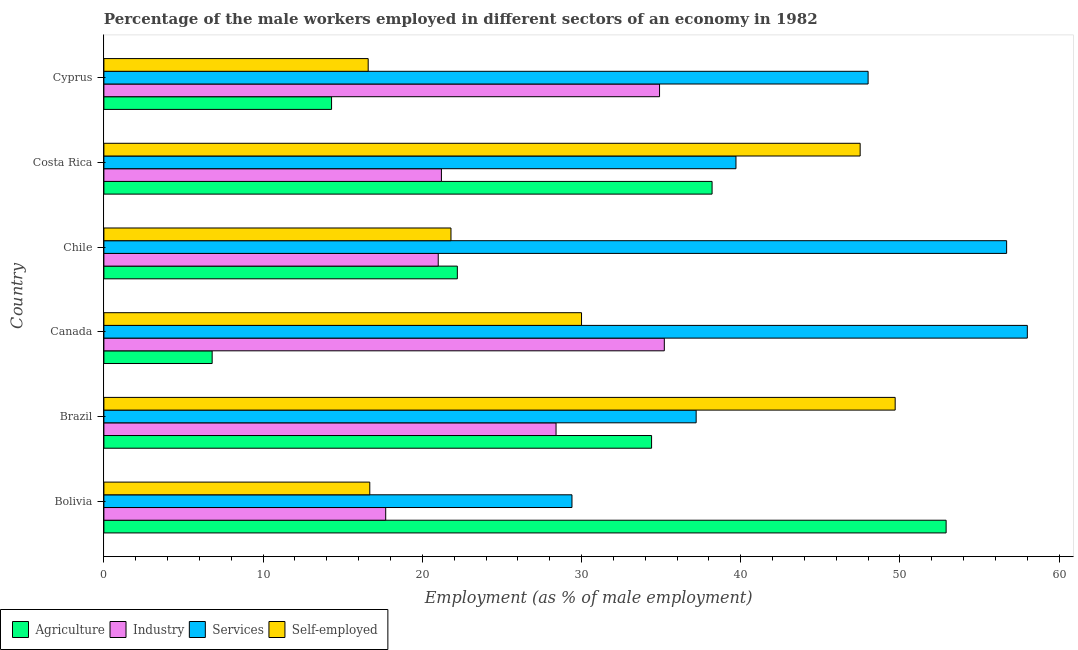How many different coloured bars are there?
Provide a short and direct response. 4. Are the number of bars per tick equal to the number of legend labels?
Ensure brevity in your answer.  Yes. Are the number of bars on each tick of the Y-axis equal?
Your answer should be compact. Yes. How many bars are there on the 1st tick from the top?
Offer a very short reply. 4. How many bars are there on the 5th tick from the bottom?
Offer a terse response. 4. In how many cases, is the number of bars for a given country not equal to the number of legend labels?
Provide a short and direct response. 0. What is the percentage of self employed male workers in Bolivia?
Your response must be concise. 16.7. Across all countries, what is the maximum percentage of self employed male workers?
Provide a succinct answer. 49.7. Across all countries, what is the minimum percentage of male workers in industry?
Make the answer very short. 17.7. What is the total percentage of male workers in services in the graph?
Give a very brief answer. 269. What is the difference between the percentage of male workers in agriculture in Brazil and that in Canada?
Give a very brief answer. 27.6. What is the difference between the percentage of male workers in services in Canada and the percentage of male workers in industry in Bolivia?
Offer a terse response. 40.3. What is the average percentage of male workers in agriculture per country?
Your answer should be very brief. 28.13. What is the difference between the percentage of male workers in industry and percentage of self employed male workers in Brazil?
Your answer should be very brief. -21.3. What is the ratio of the percentage of male workers in services in Bolivia to that in Cyprus?
Provide a short and direct response. 0.61. Is the percentage of male workers in industry in Brazil less than that in Chile?
Provide a succinct answer. No. Is the difference between the percentage of self employed male workers in Canada and Cyprus greater than the difference between the percentage of male workers in agriculture in Canada and Cyprus?
Keep it short and to the point. Yes. What is the difference between the highest and the lowest percentage of male workers in agriculture?
Keep it short and to the point. 46.1. In how many countries, is the percentage of male workers in services greater than the average percentage of male workers in services taken over all countries?
Provide a succinct answer. 3. Is the sum of the percentage of male workers in services in Bolivia and Brazil greater than the maximum percentage of male workers in agriculture across all countries?
Keep it short and to the point. Yes. Is it the case that in every country, the sum of the percentage of male workers in industry and percentage of male workers in services is greater than the sum of percentage of male workers in agriculture and percentage of self employed male workers?
Your answer should be very brief. Yes. What does the 4th bar from the top in Costa Rica represents?
Offer a very short reply. Agriculture. What does the 2nd bar from the bottom in Chile represents?
Your answer should be very brief. Industry. Are all the bars in the graph horizontal?
Make the answer very short. Yes. How many countries are there in the graph?
Offer a very short reply. 6. Does the graph contain any zero values?
Ensure brevity in your answer.  No. What is the title of the graph?
Provide a short and direct response. Percentage of the male workers employed in different sectors of an economy in 1982. Does "Mammal species" appear as one of the legend labels in the graph?
Offer a terse response. No. What is the label or title of the X-axis?
Make the answer very short. Employment (as % of male employment). What is the label or title of the Y-axis?
Give a very brief answer. Country. What is the Employment (as % of male employment) of Agriculture in Bolivia?
Your answer should be very brief. 52.9. What is the Employment (as % of male employment) in Industry in Bolivia?
Keep it short and to the point. 17.7. What is the Employment (as % of male employment) of Services in Bolivia?
Offer a terse response. 29.4. What is the Employment (as % of male employment) in Self-employed in Bolivia?
Provide a short and direct response. 16.7. What is the Employment (as % of male employment) in Agriculture in Brazil?
Keep it short and to the point. 34.4. What is the Employment (as % of male employment) in Industry in Brazil?
Your response must be concise. 28.4. What is the Employment (as % of male employment) of Services in Brazil?
Provide a succinct answer. 37.2. What is the Employment (as % of male employment) in Self-employed in Brazil?
Give a very brief answer. 49.7. What is the Employment (as % of male employment) of Agriculture in Canada?
Keep it short and to the point. 6.8. What is the Employment (as % of male employment) of Industry in Canada?
Offer a terse response. 35.2. What is the Employment (as % of male employment) in Agriculture in Chile?
Ensure brevity in your answer.  22.2. What is the Employment (as % of male employment) of Industry in Chile?
Your answer should be compact. 21. What is the Employment (as % of male employment) in Services in Chile?
Provide a short and direct response. 56.7. What is the Employment (as % of male employment) in Self-employed in Chile?
Ensure brevity in your answer.  21.8. What is the Employment (as % of male employment) of Agriculture in Costa Rica?
Keep it short and to the point. 38.2. What is the Employment (as % of male employment) of Industry in Costa Rica?
Your answer should be compact. 21.2. What is the Employment (as % of male employment) of Services in Costa Rica?
Your answer should be very brief. 39.7. What is the Employment (as % of male employment) of Self-employed in Costa Rica?
Keep it short and to the point. 47.5. What is the Employment (as % of male employment) in Agriculture in Cyprus?
Provide a succinct answer. 14.3. What is the Employment (as % of male employment) of Industry in Cyprus?
Your response must be concise. 34.9. What is the Employment (as % of male employment) of Self-employed in Cyprus?
Provide a short and direct response. 16.6. Across all countries, what is the maximum Employment (as % of male employment) in Agriculture?
Offer a terse response. 52.9. Across all countries, what is the maximum Employment (as % of male employment) of Industry?
Your answer should be very brief. 35.2. Across all countries, what is the maximum Employment (as % of male employment) of Services?
Make the answer very short. 58. Across all countries, what is the maximum Employment (as % of male employment) in Self-employed?
Your answer should be compact. 49.7. Across all countries, what is the minimum Employment (as % of male employment) in Agriculture?
Give a very brief answer. 6.8. Across all countries, what is the minimum Employment (as % of male employment) in Industry?
Your answer should be very brief. 17.7. Across all countries, what is the minimum Employment (as % of male employment) in Services?
Make the answer very short. 29.4. Across all countries, what is the minimum Employment (as % of male employment) in Self-employed?
Keep it short and to the point. 16.6. What is the total Employment (as % of male employment) of Agriculture in the graph?
Keep it short and to the point. 168.8. What is the total Employment (as % of male employment) of Industry in the graph?
Your answer should be very brief. 158.4. What is the total Employment (as % of male employment) of Services in the graph?
Provide a succinct answer. 269. What is the total Employment (as % of male employment) of Self-employed in the graph?
Your response must be concise. 182.3. What is the difference between the Employment (as % of male employment) of Industry in Bolivia and that in Brazil?
Offer a very short reply. -10.7. What is the difference between the Employment (as % of male employment) in Self-employed in Bolivia and that in Brazil?
Provide a succinct answer. -33. What is the difference between the Employment (as % of male employment) of Agriculture in Bolivia and that in Canada?
Give a very brief answer. 46.1. What is the difference between the Employment (as % of male employment) in Industry in Bolivia and that in Canada?
Your response must be concise. -17.5. What is the difference between the Employment (as % of male employment) of Services in Bolivia and that in Canada?
Offer a very short reply. -28.6. What is the difference between the Employment (as % of male employment) in Agriculture in Bolivia and that in Chile?
Provide a succinct answer. 30.7. What is the difference between the Employment (as % of male employment) in Industry in Bolivia and that in Chile?
Give a very brief answer. -3.3. What is the difference between the Employment (as % of male employment) of Services in Bolivia and that in Chile?
Your response must be concise. -27.3. What is the difference between the Employment (as % of male employment) in Self-employed in Bolivia and that in Chile?
Your response must be concise. -5.1. What is the difference between the Employment (as % of male employment) of Agriculture in Bolivia and that in Costa Rica?
Offer a terse response. 14.7. What is the difference between the Employment (as % of male employment) in Services in Bolivia and that in Costa Rica?
Keep it short and to the point. -10.3. What is the difference between the Employment (as % of male employment) of Self-employed in Bolivia and that in Costa Rica?
Your answer should be very brief. -30.8. What is the difference between the Employment (as % of male employment) in Agriculture in Bolivia and that in Cyprus?
Provide a succinct answer. 38.6. What is the difference between the Employment (as % of male employment) of Industry in Bolivia and that in Cyprus?
Make the answer very short. -17.2. What is the difference between the Employment (as % of male employment) in Services in Bolivia and that in Cyprus?
Offer a terse response. -18.6. What is the difference between the Employment (as % of male employment) of Self-employed in Bolivia and that in Cyprus?
Provide a succinct answer. 0.1. What is the difference between the Employment (as % of male employment) in Agriculture in Brazil and that in Canada?
Keep it short and to the point. 27.6. What is the difference between the Employment (as % of male employment) in Industry in Brazil and that in Canada?
Your answer should be compact. -6.8. What is the difference between the Employment (as % of male employment) in Services in Brazil and that in Canada?
Keep it short and to the point. -20.8. What is the difference between the Employment (as % of male employment) of Agriculture in Brazil and that in Chile?
Provide a short and direct response. 12.2. What is the difference between the Employment (as % of male employment) of Industry in Brazil and that in Chile?
Ensure brevity in your answer.  7.4. What is the difference between the Employment (as % of male employment) in Services in Brazil and that in Chile?
Your answer should be very brief. -19.5. What is the difference between the Employment (as % of male employment) in Self-employed in Brazil and that in Chile?
Offer a very short reply. 27.9. What is the difference between the Employment (as % of male employment) in Services in Brazil and that in Costa Rica?
Provide a short and direct response. -2.5. What is the difference between the Employment (as % of male employment) of Agriculture in Brazil and that in Cyprus?
Your response must be concise. 20.1. What is the difference between the Employment (as % of male employment) in Industry in Brazil and that in Cyprus?
Provide a short and direct response. -6.5. What is the difference between the Employment (as % of male employment) in Services in Brazil and that in Cyprus?
Your response must be concise. -10.8. What is the difference between the Employment (as % of male employment) of Self-employed in Brazil and that in Cyprus?
Your response must be concise. 33.1. What is the difference between the Employment (as % of male employment) of Agriculture in Canada and that in Chile?
Your response must be concise. -15.4. What is the difference between the Employment (as % of male employment) of Agriculture in Canada and that in Costa Rica?
Offer a very short reply. -31.4. What is the difference between the Employment (as % of male employment) of Industry in Canada and that in Costa Rica?
Provide a short and direct response. 14. What is the difference between the Employment (as % of male employment) in Self-employed in Canada and that in Costa Rica?
Ensure brevity in your answer.  -17.5. What is the difference between the Employment (as % of male employment) of Industry in Canada and that in Cyprus?
Your answer should be very brief. 0.3. What is the difference between the Employment (as % of male employment) of Self-employed in Canada and that in Cyprus?
Provide a succinct answer. 13.4. What is the difference between the Employment (as % of male employment) in Agriculture in Chile and that in Costa Rica?
Ensure brevity in your answer.  -16. What is the difference between the Employment (as % of male employment) in Services in Chile and that in Costa Rica?
Your answer should be compact. 17. What is the difference between the Employment (as % of male employment) in Self-employed in Chile and that in Costa Rica?
Your answer should be very brief. -25.7. What is the difference between the Employment (as % of male employment) of Agriculture in Chile and that in Cyprus?
Give a very brief answer. 7.9. What is the difference between the Employment (as % of male employment) in Industry in Chile and that in Cyprus?
Make the answer very short. -13.9. What is the difference between the Employment (as % of male employment) of Services in Chile and that in Cyprus?
Provide a short and direct response. 8.7. What is the difference between the Employment (as % of male employment) in Agriculture in Costa Rica and that in Cyprus?
Your answer should be compact. 23.9. What is the difference between the Employment (as % of male employment) of Industry in Costa Rica and that in Cyprus?
Offer a very short reply. -13.7. What is the difference between the Employment (as % of male employment) of Self-employed in Costa Rica and that in Cyprus?
Your answer should be compact. 30.9. What is the difference between the Employment (as % of male employment) in Agriculture in Bolivia and the Employment (as % of male employment) in Industry in Brazil?
Keep it short and to the point. 24.5. What is the difference between the Employment (as % of male employment) in Industry in Bolivia and the Employment (as % of male employment) in Services in Brazil?
Give a very brief answer. -19.5. What is the difference between the Employment (as % of male employment) of Industry in Bolivia and the Employment (as % of male employment) of Self-employed in Brazil?
Your response must be concise. -32. What is the difference between the Employment (as % of male employment) of Services in Bolivia and the Employment (as % of male employment) of Self-employed in Brazil?
Make the answer very short. -20.3. What is the difference between the Employment (as % of male employment) in Agriculture in Bolivia and the Employment (as % of male employment) in Services in Canada?
Your response must be concise. -5.1. What is the difference between the Employment (as % of male employment) of Agriculture in Bolivia and the Employment (as % of male employment) of Self-employed in Canada?
Give a very brief answer. 22.9. What is the difference between the Employment (as % of male employment) of Industry in Bolivia and the Employment (as % of male employment) of Services in Canada?
Your answer should be very brief. -40.3. What is the difference between the Employment (as % of male employment) in Services in Bolivia and the Employment (as % of male employment) in Self-employed in Canada?
Give a very brief answer. -0.6. What is the difference between the Employment (as % of male employment) of Agriculture in Bolivia and the Employment (as % of male employment) of Industry in Chile?
Ensure brevity in your answer.  31.9. What is the difference between the Employment (as % of male employment) of Agriculture in Bolivia and the Employment (as % of male employment) of Self-employed in Chile?
Provide a succinct answer. 31.1. What is the difference between the Employment (as % of male employment) of Industry in Bolivia and the Employment (as % of male employment) of Services in Chile?
Your answer should be very brief. -39. What is the difference between the Employment (as % of male employment) in Agriculture in Bolivia and the Employment (as % of male employment) in Industry in Costa Rica?
Provide a succinct answer. 31.7. What is the difference between the Employment (as % of male employment) in Industry in Bolivia and the Employment (as % of male employment) in Self-employed in Costa Rica?
Provide a short and direct response. -29.8. What is the difference between the Employment (as % of male employment) of Services in Bolivia and the Employment (as % of male employment) of Self-employed in Costa Rica?
Your answer should be very brief. -18.1. What is the difference between the Employment (as % of male employment) of Agriculture in Bolivia and the Employment (as % of male employment) of Industry in Cyprus?
Keep it short and to the point. 18. What is the difference between the Employment (as % of male employment) of Agriculture in Bolivia and the Employment (as % of male employment) of Self-employed in Cyprus?
Give a very brief answer. 36.3. What is the difference between the Employment (as % of male employment) of Industry in Bolivia and the Employment (as % of male employment) of Services in Cyprus?
Your answer should be compact. -30.3. What is the difference between the Employment (as % of male employment) of Services in Bolivia and the Employment (as % of male employment) of Self-employed in Cyprus?
Your answer should be compact. 12.8. What is the difference between the Employment (as % of male employment) in Agriculture in Brazil and the Employment (as % of male employment) in Industry in Canada?
Give a very brief answer. -0.8. What is the difference between the Employment (as % of male employment) in Agriculture in Brazil and the Employment (as % of male employment) in Services in Canada?
Make the answer very short. -23.6. What is the difference between the Employment (as % of male employment) in Agriculture in Brazil and the Employment (as % of male employment) in Self-employed in Canada?
Keep it short and to the point. 4.4. What is the difference between the Employment (as % of male employment) in Industry in Brazil and the Employment (as % of male employment) in Services in Canada?
Offer a terse response. -29.6. What is the difference between the Employment (as % of male employment) in Industry in Brazil and the Employment (as % of male employment) in Self-employed in Canada?
Your answer should be compact. -1.6. What is the difference between the Employment (as % of male employment) of Agriculture in Brazil and the Employment (as % of male employment) of Services in Chile?
Offer a very short reply. -22.3. What is the difference between the Employment (as % of male employment) in Agriculture in Brazil and the Employment (as % of male employment) in Self-employed in Chile?
Provide a short and direct response. 12.6. What is the difference between the Employment (as % of male employment) of Industry in Brazil and the Employment (as % of male employment) of Services in Chile?
Offer a terse response. -28.3. What is the difference between the Employment (as % of male employment) in Industry in Brazil and the Employment (as % of male employment) in Self-employed in Chile?
Ensure brevity in your answer.  6.6. What is the difference between the Employment (as % of male employment) in Industry in Brazil and the Employment (as % of male employment) in Self-employed in Costa Rica?
Offer a very short reply. -19.1. What is the difference between the Employment (as % of male employment) of Agriculture in Brazil and the Employment (as % of male employment) of Industry in Cyprus?
Your response must be concise. -0.5. What is the difference between the Employment (as % of male employment) in Agriculture in Brazil and the Employment (as % of male employment) in Services in Cyprus?
Keep it short and to the point. -13.6. What is the difference between the Employment (as % of male employment) of Industry in Brazil and the Employment (as % of male employment) of Services in Cyprus?
Make the answer very short. -19.6. What is the difference between the Employment (as % of male employment) in Services in Brazil and the Employment (as % of male employment) in Self-employed in Cyprus?
Your response must be concise. 20.6. What is the difference between the Employment (as % of male employment) in Agriculture in Canada and the Employment (as % of male employment) in Industry in Chile?
Your answer should be compact. -14.2. What is the difference between the Employment (as % of male employment) of Agriculture in Canada and the Employment (as % of male employment) of Services in Chile?
Provide a short and direct response. -49.9. What is the difference between the Employment (as % of male employment) in Industry in Canada and the Employment (as % of male employment) in Services in Chile?
Make the answer very short. -21.5. What is the difference between the Employment (as % of male employment) in Services in Canada and the Employment (as % of male employment) in Self-employed in Chile?
Your answer should be very brief. 36.2. What is the difference between the Employment (as % of male employment) of Agriculture in Canada and the Employment (as % of male employment) of Industry in Costa Rica?
Ensure brevity in your answer.  -14.4. What is the difference between the Employment (as % of male employment) of Agriculture in Canada and the Employment (as % of male employment) of Services in Costa Rica?
Provide a succinct answer. -32.9. What is the difference between the Employment (as % of male employment) in Agriculture in Canada and the Employment (as % of male employment) in Self-employed in Costa Rica?
Give a very brief answer. -40.7. What is the difference between the Employment (as % of male employment) in Industry in Canada and the Employment (as % of male employment) in Services in Costa Rica?
Your answer should be very brief. -4.5. What is the difference between the Employment (as % of male employment) in Industry in Canada and the Employment (as % of male employment) in Self-employed in Costa Rica?
Give a very brief answer. -12.3. What is the difference between the Employment (as % of male employment) of Services in Canada and the Employment (as % of male employment) of Self-employed in Costa Rica?
Your answer should be compact. 10.5. What is the difference between the Employment (as % of male employment) of Agriculture in Canada and the Employment (as % of male employment) of Industry in Cyprus?
Ensure brevity in your answer.  -28.1. What is the difference between the Employment (as % of male employment) in Agriculture in Canada and the Employment (as % of male employment) in Services in Cyprus?
Offer a terse response. -41.2. What is the difference between the Employment (as % of male employment) in Agriculture in Canada and the Employment (as % of male employment) in Self-employed in Cyprus?
Make the answer very short. -9.8. What is the difference between the Employment (as % of male employment) in Services in Canada and the Employment (as % of male employment) in Self-employed in Cyprus?
Provide a succinct answer. 41.4. What is the difference between the Employment (as % of male employment) of Agriculture in Chile and the Employment (as % of male employment) of Services in Costa Rica?
Provide a succinct answer. -17.5. What is the difference between the Employment (as % of male employment) in Agriculture in Chile and the Employment (as % of male employment) in Self-employed in Costa Rica?
Ensure brevity in your answer.  -25.3. What is the difference between the Employment (as % of male employment) of Industry in Chile and the Employment (as % of male employment) of Services in Costa Rica?
Give a very brief answer. -18.7. What is the difference between the Employment (as % of male employment) in Industry in Chile and the Employment (as % of male employment) in Self-employed in Costa Rica?
Offer a very short reply. -26.5. What is the difference between the Employment (as % of male employment) in Agriculture in Chile and the Employment (as % of male employment) in Industry in Cyprus?
Provide a succinct answer. -12.7. What is the difference between the Employment (as % of male employment) in Agriculture in Chile and the Employment (as % of male employment) in Services in Cyprus?
Offer a terse response. -25.8. What is the difference between the Employment (as % of male employment) of Services in Chile and the Employment (as % of male employment) of Self-employed in Cyprus?
Offer a very short reply. 40.1. What is the difference between the Employment (as % of male employment) of Agriculture in Costa Rica and the Employment (as % of male employment) of Industry in Cyprus?
Keep it short and to the point. 3.3. What is the difference between the Employment (as % of male employment) of Agriculture in Costa Rica and the Employment (as % of male employment) of Services in Cyprus?
Give a very brief answer. -9.8. What is the difference between the Employment (as % of male employment) of Agriculture in Costa Rica and the Employment (as % of male employment) of Self-employed in Cyprus?
Give a very brief answer. 21.6. What is the difference between the Employment (as % of male employment) of Industry in Costa Rica and the Employment (as % of male employment) of Services in Cyprus?
Your answer should be compact. -26.8. What is the difference between the Employment (as % of male employment) in Industry in Costa Rica and the Employment (as % of male employment) in Self-employed in Cyprus?
Provide a succinct answer. 4.6. What is the difference between the Employment (as % of male employment) in Services in Costa Rica and the Employment (as % of male employment) in Self-employed in Cyprus?
Ensure brevity in your answer.  23.1. What is the average Employment (as % of male employment) in Agriculture per country?
Provide a succinct answer. 28.13. What is the average Employment (as % of male employment) in Industry per country?
Your response must be concise. 26.4. What is the average Employment (as % of male employment) in Services per country?
Provide a short and direct response. 44.83. What is the average Employment (as % of male employment) in Self-employed per country?
Offer a terse response. 30.38. What is the difference between the Employment (as % of male employment) of Agriculture and Employment (as % of male employment) of Industry in Bolivia?
Make the answer very short. 35.2. What is the difference between the Employment (as % of male employment) in Agriculture and Employment (as % of male employment) in Self-employed in Bolivia?
Your answer should be very brief. 36.2. What is the difference between the Employment (as % of male employment) in Services and Employment (as % of male employment) in Self-employed in Bolivia?
Your response must be concise. 12.7. What is the difference between the Employment (as % of male employment) in Agriculture and Employment (as % of male employment) in Industry in Brazil?
Your answer should be very brief. 6. What is the difference between the Employment (as % of male employment) of Agriculture and Employment (as % of male employment) of Services in Brazil?
Your answer should be very brief. -2.8. What is the difference between the Employment (as % of male employment) of Agriculture and Employment (as % of male employment) of Self-employed in Brazil?
Provide a succinct answer. -15.3. What is the difference between the Employment (as % of male employment) of Industry and Employment (as % of male employment) of Self-employed in Brazil?
Your answer should be very brief. -21.3. What is the difference between the Employment (as % of male employment) in Agriculture and Employment (as % of male employment) in Industry in Canada?
Your response must be concise. -28.4. What is the difference between the Employment (as % of male employment) of Agriculture and Employment (as % of male employment) of Services in Canada?
Provide a short and direct response. -51.2. What is the difference between the Employment (as % of male employment) in Agriculture and Employment (as % of male employment) in Self-employed in Canada?
Make the answer very short. -23.2. What is the difference between the Employment (as % of male employment) in Industry and Employment (as % of male employment) in Services in Canada?
Your response must be concise. -22.8. What is the difference between the Employment (as % of male employment) in Industry and Employment (as % of male employment) in Self-employed in Canada?
Ensure brevity in your answer.  5.2. What is the difference between the Employment (as % of male employment) of Services and Employment (as % of male employment) of Self-employed in Canada?
Offer a terse response. 28. What is the difference between the Employment (as % of male employment) in Agriculture and Employment (as % of male employment) in Services in Chile?
Offer a very short reply. -34.5. What is the difference between the Employment (as % of male employment) in Industry and Employment (as % of male employment) in Services in Chile?
Give a very brief answer. -35.7. What is the difference between the Employment (as % of male employment) in Industry and Employment (as % of male employment) in Self-employed in Chile?
Your answer should be very brief. -0.8. What is the difference between the Employment (as % of male employment) of Services and Employment (as % of male employment) of Self-employed in Chile?
Keep it short and to the point. 34.9. What is the difference between the Employment (as % of male employment) in Agriculture and Employment (as % of male employment) in Self-employed in Costa Rica?
Provide a short and direct response. -9.3. What is the difference between the Employment (as % of male employment) in Industry and Employment (as % of male employment) in Services in Costa Rica?
Your answer should be compact. -18.5. What is the difference between the Employment (as % of male employment) in Industry and Employment (as % of male employment) in Self-employed in Costa Rica?
Your response must be concise. -26.3. What is the difference between the Employment (as % of male employment) in Agriculture and Employment (as % of male employment) in Industry in Cyprus?
Keep it short and to the point. -20.6. What is the difference between the Employment (as % of male employment) of Agriculture and Employment (as % of male employment) of Services in Cyprus?
Your response must be concise. -33.7. What is the difference between the Employment (as % of male employment) in Industry and Employment (as % of male employment) in Services in Cyprus?
Make the answer very short. -13.1. What is the difference between the Employment (as % of male employment) in Services and Employment (as % of male employment) in Self-employed in Cyprus?
Your response must be concise. 31.4. What is the ratio of the Employment (as % of male employment) of Agriculture in Bolivia to that in Brazil?
Your answer should be very brief. 1.54. What is the ratio of the Employment (as % of male employment) of Industry in Bolivia to that in Brazil?
Offer a very short reply. 0.62. What is the ratio of the Employment (as % of male employment) in Services in Bolivia to that in Brazil?
Keep it short and to the point. 0.79. What is the ratio of the Employment (as % of male employment) of Self-employed in Bolivia to that in Brazil?
Your response must be concise. 0.34. What is the ratio of the Employment (as % of male employment) in Agriculture in Bolivia to that in Canada?
Provide a succinct answer. 7.78. What is the ratio of the Employment (as % of male employment) in Industry in Bolivia to that in Canada?
Make the answer very short. 0.5. What is the ratio of the Employment (as % of male employment) of Services in Bolivia to that in Canada?
Make the answer very short. 0.51. What is the ratio of the Employment (as % of male employment) of Self-employed in Bolivia to that in Canada?
Offer a terse response. 0.56. What is the ratio of the Employment (as % of male employment) in Agriculture in Bolivia to that in Chile?
Provide a short and direct response. 2.38. What is the ratio of the Employment (as % of male employment) in Industry in Bolivia to that in Chile?
Provide a succinct answer. 0.84. What is the ratio of the Employment (as % of male employment) in Services in Bolivia to that in Chile?
Ensure brevity in your answer.  0.52. What is the ratio of the Employment (as % of male employment) of Self-employed in Bolivia to that in Chile?
Give a very brief answer. 0.77. What is the ratio of the Employment (as % of male employment) in Agriculture in Bolivia to that in Costa Rica?
Give a very brief answer. 1.38. What is the ratio of the Employment (as % of male employment) in Industry in Bolivia to that in Costa Rica?
Keep it short and to the point. 0.83. What is the ratio of the Employment (as % of male employment) of Services in Bolivia to that in Costa Rica?
Provide a succinct answer. 0.74. What is the ratio of the Employment (as % of male employment) in Self-employed in Bolivia to that in Costa Rica?
Make the answer very short. 0.35. What is the ratio of the Employment (as % of male employment) of Agriculture in Bolivia to that in Cyprus?
Make the answer very short. 3.7. What is the ratio of the Employment (as % of male employment) of Industry in Bolivia to that in Cyprus?
Provide a succinct answer. 0.51. What is the ratio of the Employment (as % of male employment) in Services in Bolivia to that in Cyprus?
Your answer should be compact. 0.61. What is the ratio of the Employment (as % of male employment) of Self-employed in Bolivia to that in Cyprus?
Your answer should be compact. 1.01. What is the ratio of the Employment (as % of male employment) of Agriculture in Brazil to that in Canada?
Your answer should be very brief. 5.06. What is the ratio of the Employment (as % of male employment) of Industry in Brazil to that in Canada?
Offer a very short reply. 0.81. What is the ratio of the Employment (as % of male employment) in Services in Brazil to that in Canada?
Give a very brief answer. 0.64. What is the ratio of the Employment (as % of male employment) of Self-employed in Brazil to that in Canada?
Your answer should be very brief. 1.66. What is the ratio of the Employment (as % of male employment) in Agriculture in Brazil to that in Chile?
Make the answer very short. 1.55. What is the ratio of the Employment (as % of male employment) of Industry in Brazil to that in Chile?
Provide a short and direct response. 1.35. What is the ratio of the Employment (as % of male employment) in Services in Brazil to that in Chile?
Offer a very short reply. 0.66. What is the ratio of the Employment (as % of male employment) in Self-employed in Brazil to that in Chile?
Make the answer very short. 2.28. What is the ratio of the Employment (as % of male employment) in Agriculture in Brazil to that in Costa Rica?
Offer a very short reply. 0.9. What is the ratio of the Employment (as % of male employment) in Industry in Brazil to that in Costa Rica?
Make the answer very short. 1.34. What is the ratio of the Employment (as % of male employment) of Services in Brazil to that in Costa Rica?
Your answer should be compact. 0.94. What is the ratio of the Employment (as % of male employment) in Self-employed in Brazil to that in Costa Rica?
Provide a succinct answer. 1.05. What is the ratio of the Employment (as % of male employment) in Agriculture in Brazil to that in Cyprus?
Offer a terse response. 2.41. What is the ratio of the Employment (as % of male employment) of Industry in Brazil to that in Cyprus?
Ensure brevity in your answer.  0.81. What is the ratio of the Employment (as % of male employment) of Services in Brazil to that in Cyprus?
Your answer should be compact. 0.78. What is the ratio of the Employment (as % of male employment) in Self-employed in Brazil to that in Cyprus?
Keep it short and to the point. 2.99. What is the ratio of the Employment (as % of male employment) in Agriculture in Canada to that in Chile?
Offer a very short reply. 0.31. What is the ratio of the Employment (as % of male employment) in Industry in Canada to that in Chile?
Your response must be concise. 1.68. What is the ratio of the Employment (as % of male employment) in Services in Canada to that in Chile?
Offer a very short reply. 1.02. What is the ratio of the Employment (as % of male employment) in Self-employed in Canada to that in Chile?
Your response must be concise. 1.38. What is the ratio of the Employment (as % of male employment) of Agriculture in Canada to that in Costa Rica?
Your response must be concise. 0.18. What is the ratio of the Employment (as % of male employment) of Industry in Canada to that in Costa Rica?
Keep it short and to the point. 1.66. What is the ratio of the Employment (as % of male employment) in Services in Canada to that in Costa Rica?
Offer a very short reply. 1.46. What is the ratio of the Employment (as % of male employment) in Self-employed in Canada to that in Costa Rica?
Offer a terse response. 0.63. What is the ratio of the Employment (as % of male employment) of Agriculture in Canada to that in Cyprus?
Keep it short and to the point. 0.48. What is the ratio of the Employment (as % of male employment) in Industry in Canada to that in Cyprus?
Give a very brief answer. 1.01. What is the ratio of the Employment (as % of male employment) in Services in Canada to that in Cyprus?
Offer a very short reply. 1.21. What is the ratio of the Employment (as % of male employment) of Self-employed in Canada to that in Cyprus?
Your answer should be compact. 1.81. What is the ratio of the Employment (as % of male employment) of Agriculture in Chile to that in Costa Rica?
Your answer should be very brief. 0.58. What is the ratio of the Employment (as % of male employment) of Industry in Chile to that in Costa Rica?
Offer a very short reply. 0.99. What is the ratio of the Employment (as % of male employment) in Services in Chile to that in Costa Rica?
Offer a terse response. 1.43. What is the ratio of the Employment (as % of male employment) of Self-employed in Chile to that in Costa Rica?
Provide a succinct answer. 0.46. What is the ratio of the Employment (as % of male employment) in Agriculture in Chile to that in Cyprus?
Make the answer very short. 1.55. What is the ratio of the Employment (as % of male employment) in Industry in Chile to that in Cyprus?
Keep it short and to the point. 0.6. What is the ratio of the Employment (as % of male employment) in Services in Chile to that in Cyprus?
Ensure brevity in your answer.  1.18. What is the ratio of the Employment (as % of male employment) of Self-employed in Chile to that in Cyprus?
Provide a short and direct response. 1.31. What is the ratio of the Employment (as % of male employment) of Agriculture in Costa Rica to that in Cyprus?
Your answer should be very brief. 2.67. What is the ratio of the Employment (as % of male employment) of Industry in Costa Rica to that in Cyprus?
Your answer should be very brief. 0.61. What is the ratio of the Employment (as % of male employment) in Services in Costa Rica to that in Cyprus?
Your answer should be very brief. 0.83. What is the ratio of the Employment (as % of male employment) in Self-employed in Costa Rica to that in Cyprus?
Provide a succinct answer. 2.86. What is the difference between the highest and the second highest Employment (as % of male employment) in Industry?
Your answer should be compact. 0.3. What is the difference between the highest and the second highest Employment (as % of male employment) in Self-employed?
Your response must be concise. 2.2. What is the difference between the highest and the lowest Employment (as % of male employment) of Agriculture?
Offer a terse response. 46.1. What is the difference between the highest and the lowest Employment (as % of male employment) of Services?
Your answer should be compact. 28.6. What is the difference between the highest and the lowest Employment (as % of male employment) of Self-employed?
Your answer should be compact. 33.1. 